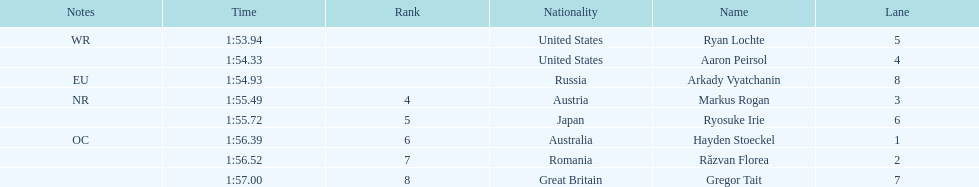Could you parse the entire table? {'header': ['Notes', 'Time', 'Rank', 'Nationality', 'Name', 'Lane'], 'rows': [['WR', '1:53.94', '', 'United States', 'Ryan Lochte', '5'], ['', '1:54.33', '', 'United States', 'Aaron Peirsol', '4'], ['EU', '1:54.93', '', 'Russia', 'Arkady Vyatchanin', '8'], ['NR', '1:55.49', '4', 'Austria', 'Markus Rogan', '3'], ['', '1:55.72', '5', 'Japan', 'Ryosuke Irie', '6'], ['OC', '1:56.39', '6', 'Australia', 'Hayden Stoeckel', '1'], ['', '1:56.52', '7', 'Romania', 'Răzvan Florea', '2'], ['', '1:57.00', '8', 'Great Britain', 'Gregor Tait', '7']]} Which country had the most medals in the competition? United States. 